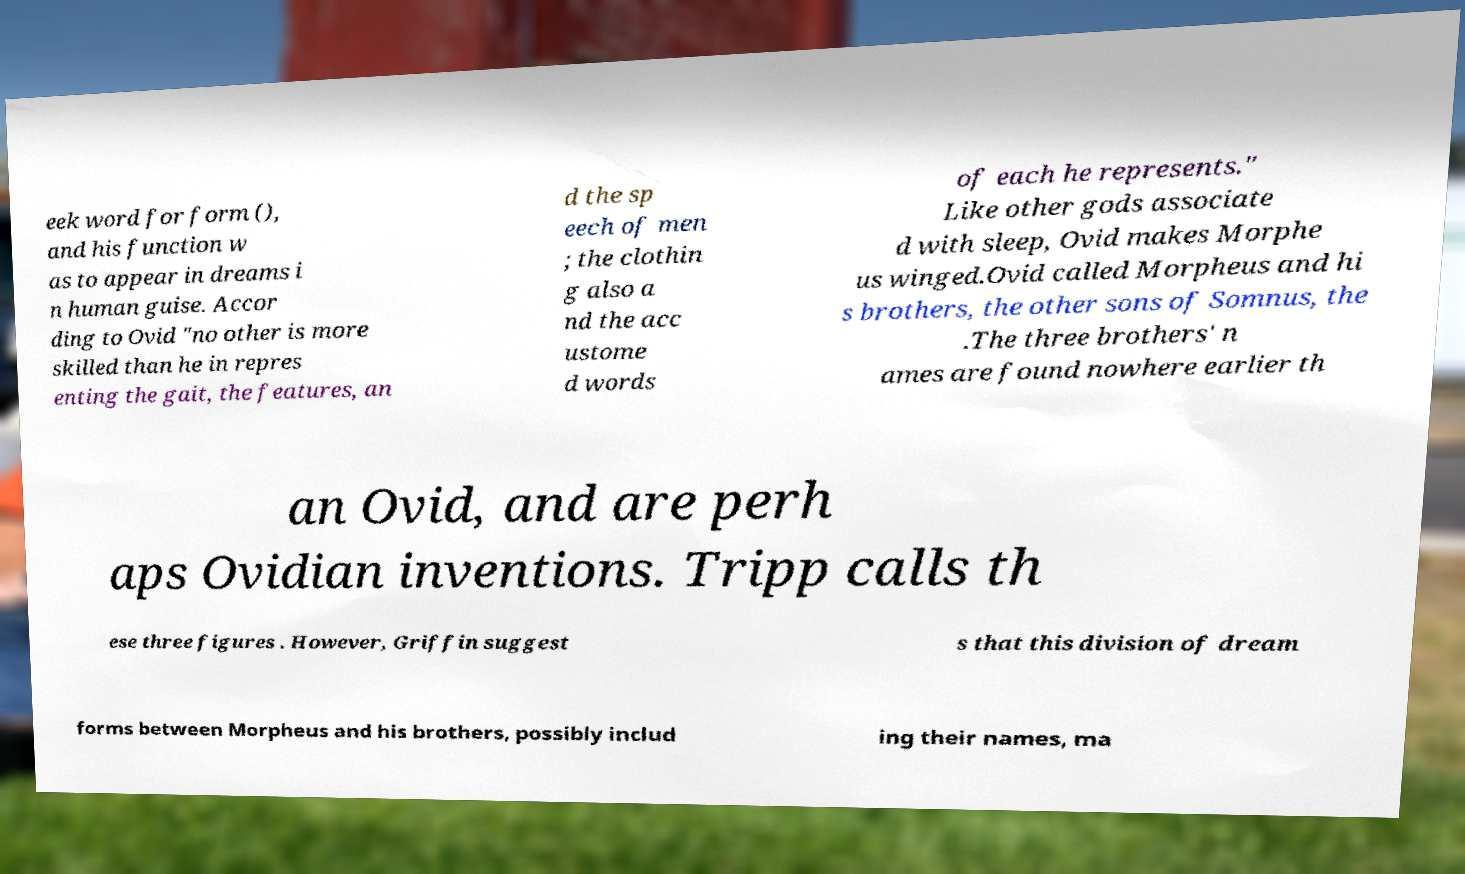Please identify and transcribe the text found in this image. eek word for form (), and his function w as to appear in dreams i n human guise. Accor ding to Ovid "no other is more skilled than he in repres enting the gait, the features, an d the sp eech of men ; the clothin g also a nd the acc ustome d words of each he represents." Like other gods associate d with sleep, Ovid makes Morphe us winged.Ovid called Morpheus and hi s brothers, the other sons of Somnus, the .The three brothers' n ames are found nowhere earlier th an Ovid, and are perh aps Ovidian inventions. Tripp calls th ese three figures . However, Griffin suggest s that this division of dream forms between Morpheus and his brothers, possibly includ ing their names, ma 